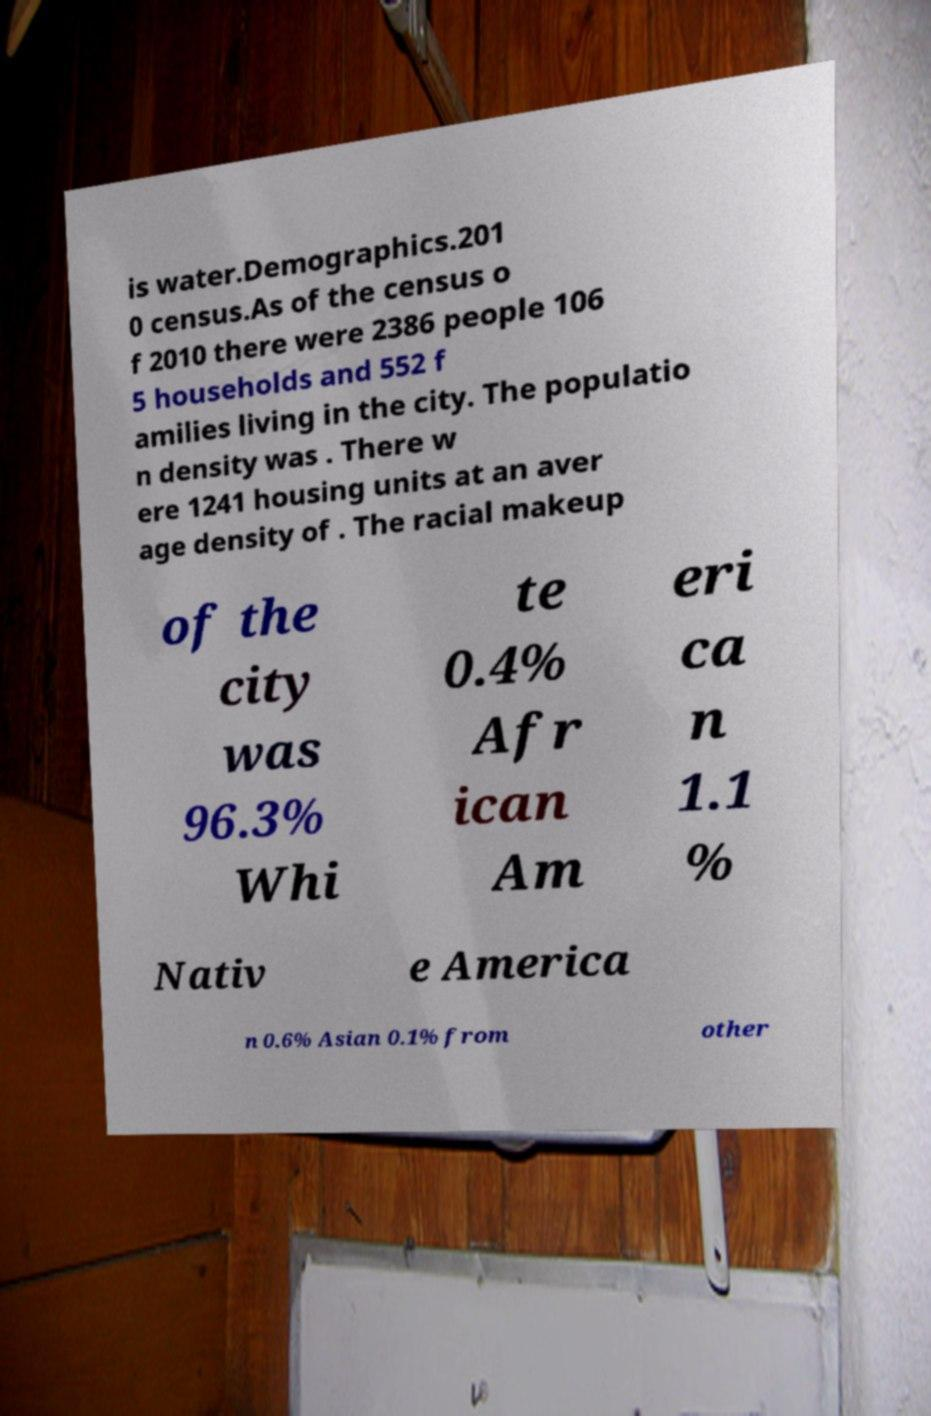Please identify and transcribe the text found in this image. is water.Demographics.201 0 census.As of the census o f 2010 there were 2386 people 106 5 households and 552 f amilies living in the city. The populatio n density was . There w ere 1241 housing units at an aver age density of . The racial makeup of the city was 96.3% Whi te 0.4% Afr ican Am eri ca n 1.1 % Nativ e America n 0.6% Asian 0.1% from other 